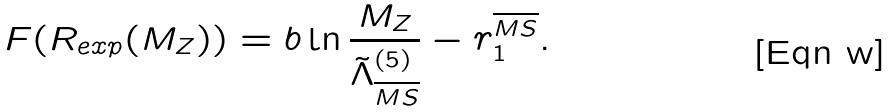Convert formula to latex. <formula><loc_0><loc_0><loc_500><loc_500>F ( R _ { e x p } ( M _ { Z } ) ) = b \ln \frac { M _ { Z } } { \tilde { \Lambda } _ { \overline { M S } } ^ { ( 5 ) } } - r _ { 1 } ^ { \overline { M S } } .</formula> 